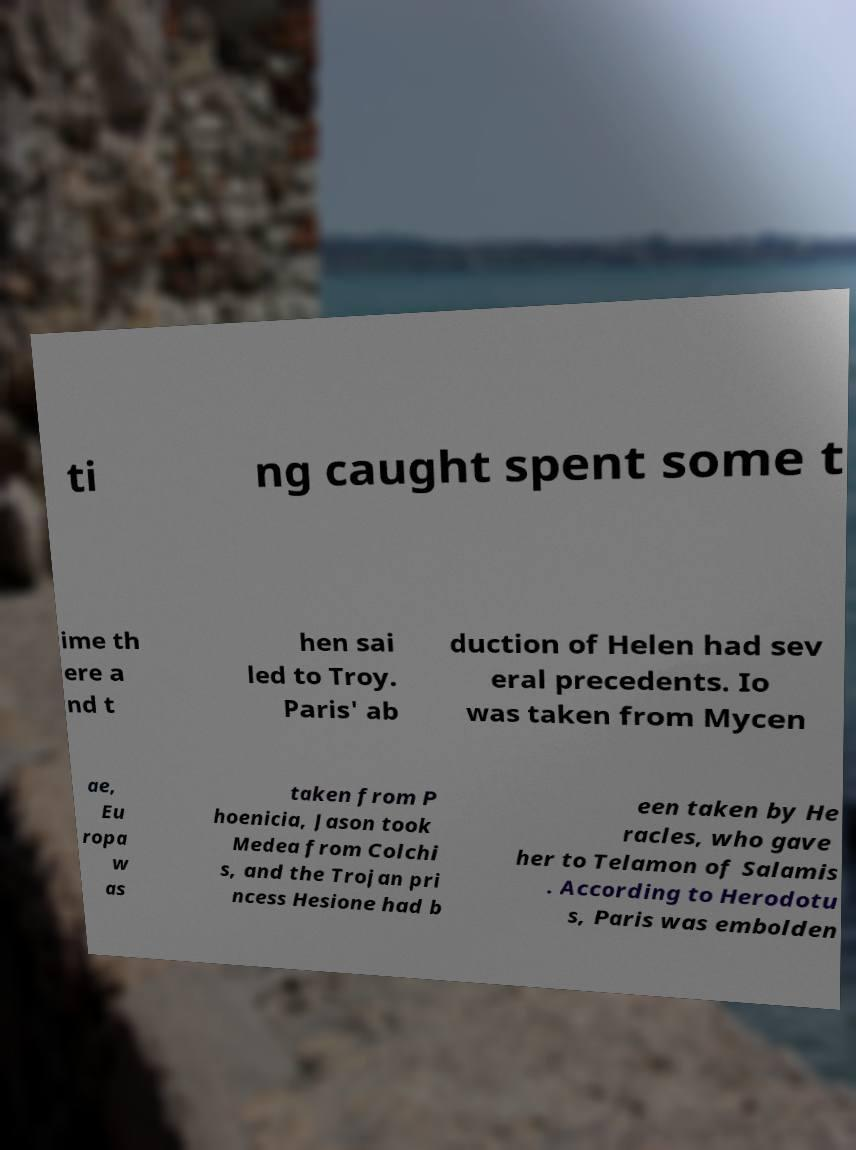Can you read and provide the text displayed in the image?This photo seems to have some interesting text. Can you extract and type it out for me? ti ng caught spent some t ime th ere a nd t hen sai led to Troy. Paris' ab duction of Helen had sev eral precedents. Io was taken from Mycen ae, Eu ropa w as taken from P hoenicia, Jason took Medea from Colchi s, and the Trojan pri ncess Hesione had b een taken by He racles, who gave her to Telamon of Salamis . According to Herodotu s, Paris was embolden 